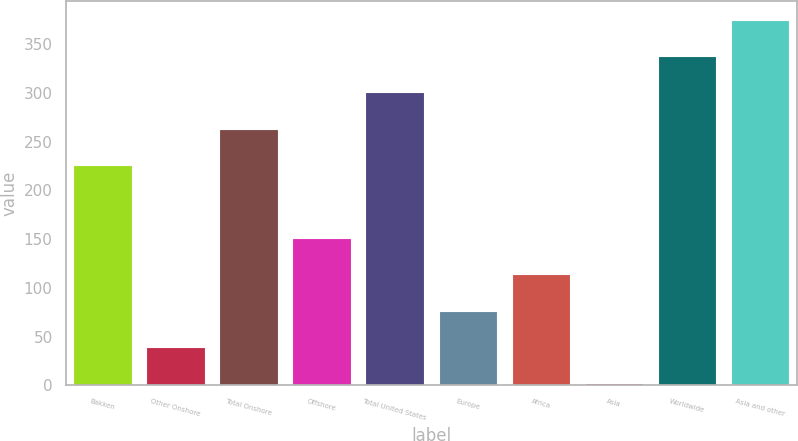<chart> <loc_0><loc_0><loc_500><loc_500><bar_chart><fcel>Bakken<fcel>Other Onshore<fcel>Total Onshore<fcel>Offshore<fcel>Total United States<fcel>Europe<fcel>Africa<fcel>Asia<fcel>Worldwide<fcel>Asia and other<nl><fcel>225.8<fcel>39.3<fcel>263.1<fcel>151.2<fcel>300.4<fcel>76.6<fcel>113.9<fcel>2<fcel>337.7<fcel>375<nl></chart> 